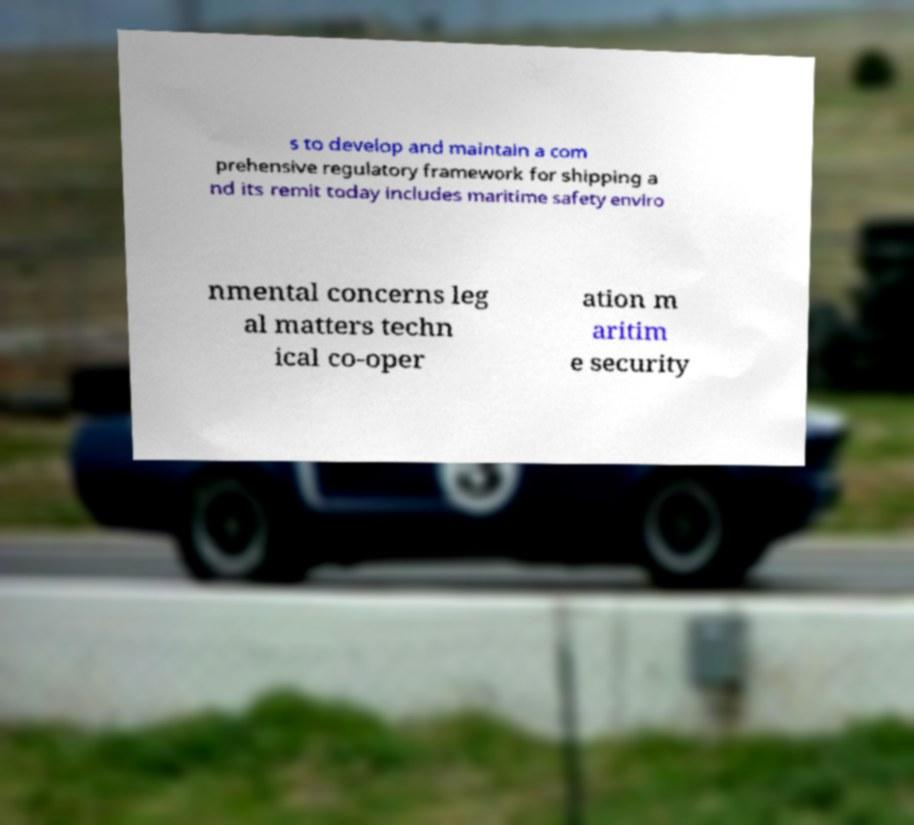Could you assist in decoding the text presented in this image and type it out clearly? s to develop and maintain a com prehensive regulatory framework for shipping a nd its remit today includes maritime safety enviro nmental concerns leg al matters techn ical co-oper ation m aritim e security 